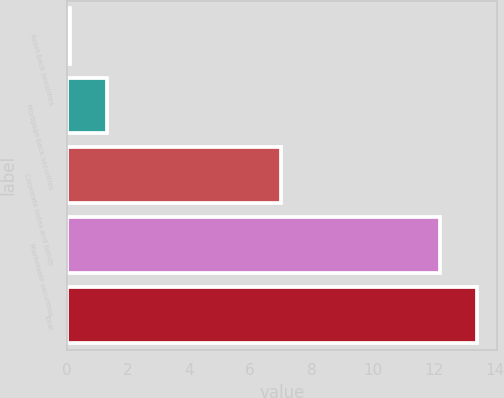<chart> <loc_0><loc_0><loc_500><loc_500><bar_chart><fcel>Asset-back securities<fcel>Mortgage-back securities<fcel>Corporate notes and bonds<fcel>Marketable securities<fcel>Total<nl><fcel>0.1<fcel>1.31<fcel>7<fcel>12.2<fcel>13.41<nl></chart> 